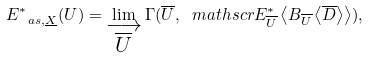Convert formula to latex. <formula><loc_0><loc_0><loc_500><loc_500>E ^ { \ast } _ { \ a s , \underline { X } } ( U ) = \lim _ { \substack { \longrightarrow \\ \overline { U } } } \Gamma ( \overline { U } , \ m a t h s c r { E } ^ { \ast } _ { \overline { U } } \left < B _ { \overline { U } } \left < \overline { D } \right > \right > ) ,</formula> 